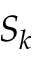Convert formula to latex. <formula><loc_0><loc_0><loc_500><loc_500>S _ { k }</formula> 